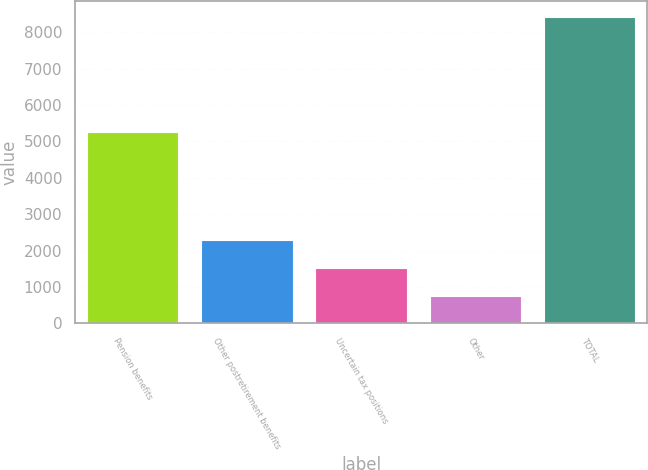Convert chart. <chart><loc_0><loc_0><loc_500><loc_500><bar_chart><fcel>Pension benefits<fcel>Other postretirement benefits<fcel>Uncertain tax positions<fcel>Other<fcel>TOTAL<nl><fcel>5247<fcel>2290.4<fcel>1522.7<fcel>755<fcel>8432<nl></chart> 